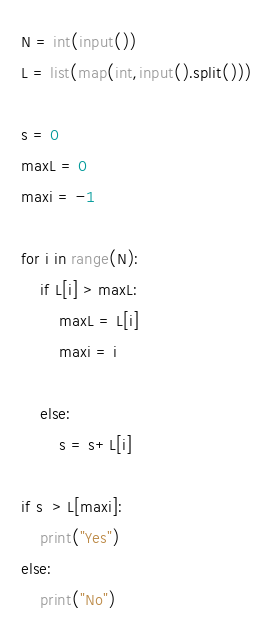<code> <loc_0><loc_0><loc_500><loc_500><_Python_>N = int(input())
L = list(map(int,input().split()))

s = 0
maxL = 0
maxi = -1

for i in range(N):
    if L[i] > maxL:
        maxL = L[i]
        maxi = i
    
    else:
        s = s+L[i]

if s  > L[maxi]:
    print("Yes")
else:
    print("No")</code> 